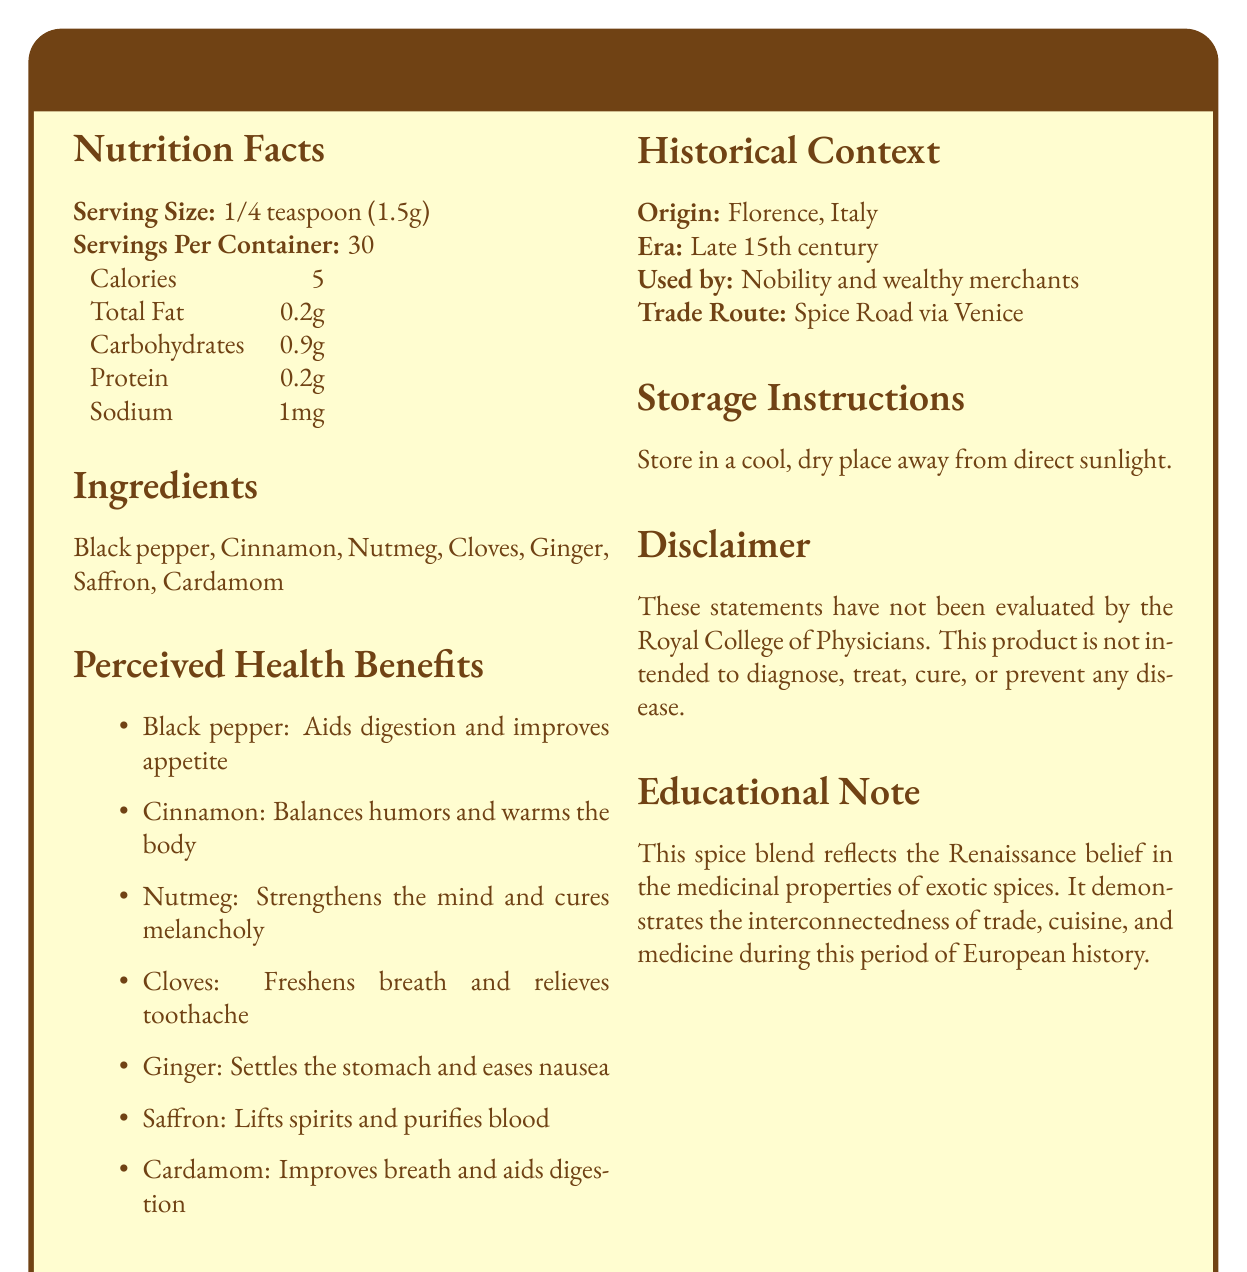what is the serving size for Medici's Spice Blend? According to the Nutrition Facts section, the serving size is listed as 1/4 teaspoon (1.5g).
Answer: 1/4 teaspoon (1.5g) how many servings per container does Medici's Spice Blend have? The Nutrition Facts section states that there are 30 servings per container.
Answer: 30 which ingredient is said to lift spirits and purify blood? The Perceived Health Benefits section indicates that saffron is believed to lift spirits and purify blood.
Answer: Saffron what is the calorie content per serving? The Nutrition Facts section lists 5 calories per serving.
Answer: 5 calories where did Medici's Spice Blend originate? The Historical Context section mentions that the origin of the spice blend is Florence, Italy.
Answer: Florence, Italy which ingredient is associated with relieving toothache? A. Black pepper B. Nutmeg C. Cloves D. Ginger The Perceived Health Benefits section mentions that cloves relieve toothache.
Answer: C. Cloves when was Medici's Spice Blend used? A. Early 14th century B. Late 15th century C. Early 16th century D. Late 17th century The Historical Context section states that the spice blend was used in the late 15th century.
Answer: B. Late 15th century does Medici's Spice Blend contain any sodium? The Nutrition Facts section lists 1mg of sodium per serving.
Answer: Yes summarize the main purpose of Medici's Spice Blend as described in the document. The document describes how the spice blend showcases the Renaissance belief in medicinal properties of spices, its historical usage by wealthy individuals, and its origins and trade routes.
Answer: Medici’s Spice Blend was a Renaissance-era spice mix believed to have medicinal properties due to its exotic ingredients. It was used by nobility and wealthy merchants and was traded via the Spice Road through Venice. The blend reflects the interconnectedness of trade, cuisine, and medicine during the Renaissance. what is the total fat content in a serving of Medici’s Spice Blend? The Nutrition Facts section indicates that the total fat content per serving is 0.2g.
Answer: 0.2g what is the main perceived health benefit of ginger according to the document? The Perceived Health Benefits section mentions that ginger settles the stomach and eases nausea.
Answer: Settles the stomach and eases nausea how should Medici's Spice Blend be stored? The Storage Instructions section instructs to store the spice blend in a cool, dry place away from direct sunlight.
Answer: Store in a cool, dry place away from direct sunlight which ingredient is said to balance humors and warm the body? The Perceived Health Benefits section lists cinnamon as the ingredient that balances humors and warms the body.
Answer: Cinnamon does the document mention how long the spice blend can be stored? The document provides storage instructions but does not mention how long the spice blend can be stored.
Answer: Not enough information which ingredient aids digestion and improves appetite? The Perceived Health Benefits section states that black pepper aids digestion and improves appetite.
Answer: Black pepper 